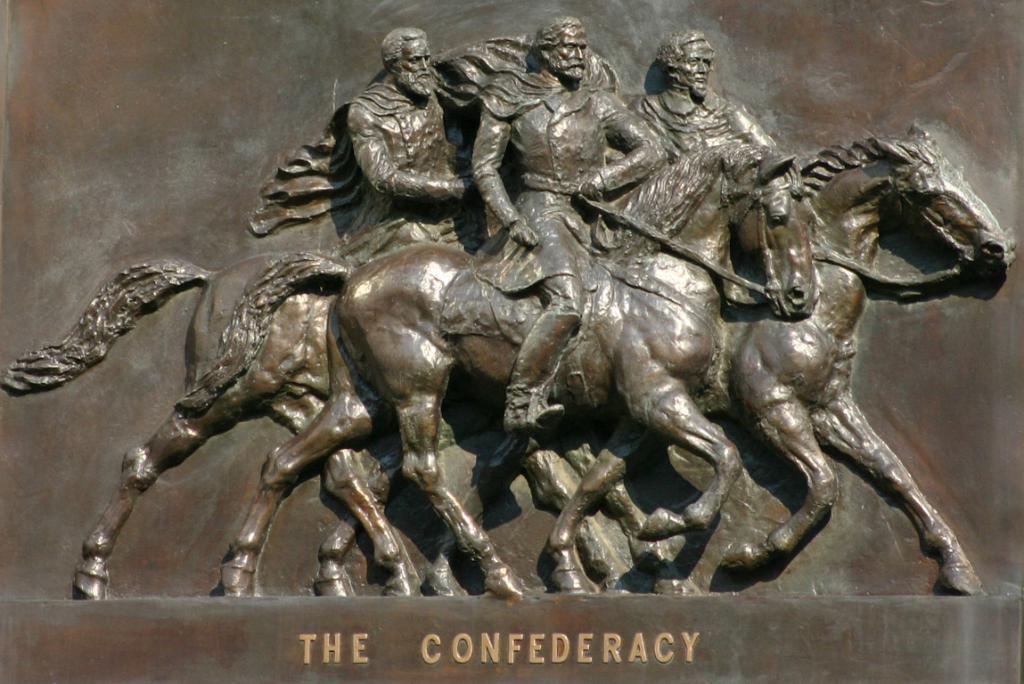Please provide a concise description of this image. In this image there is a depiction of sculpture. 